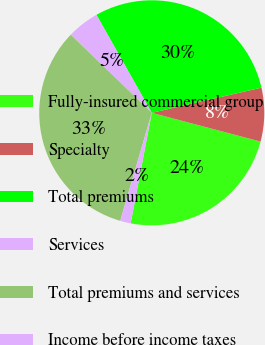Convert chart. <chart><loc_0><loc_0><loc_500><loc_500><pie_chart><fcel>Fully-insured commercial group<fcel>Specialty<fcel>Total premiums<fcel>Services<fcel>Total premiums and services<fcel>Income before income taxes<nl><fcel>23.89%<fcel>7.7%<fcel>29.59%<fcel>4.61%<fcel>32.68%<fcel>1.52%<nl></chart> 